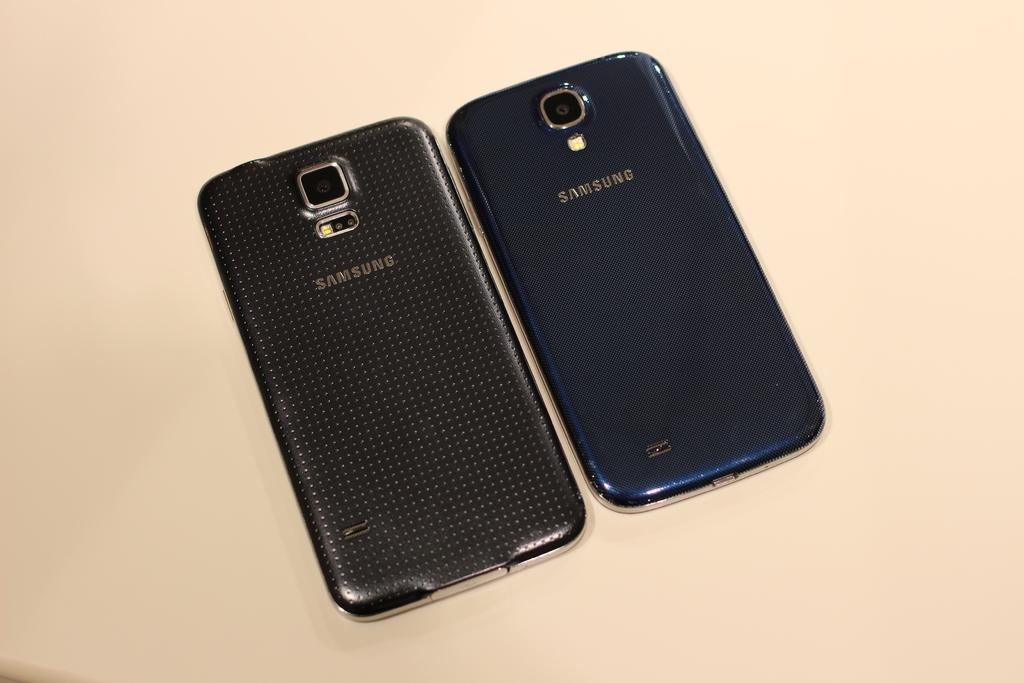Provide a one-sentence caption for the provided image. the back view of two samsung cell phones. 